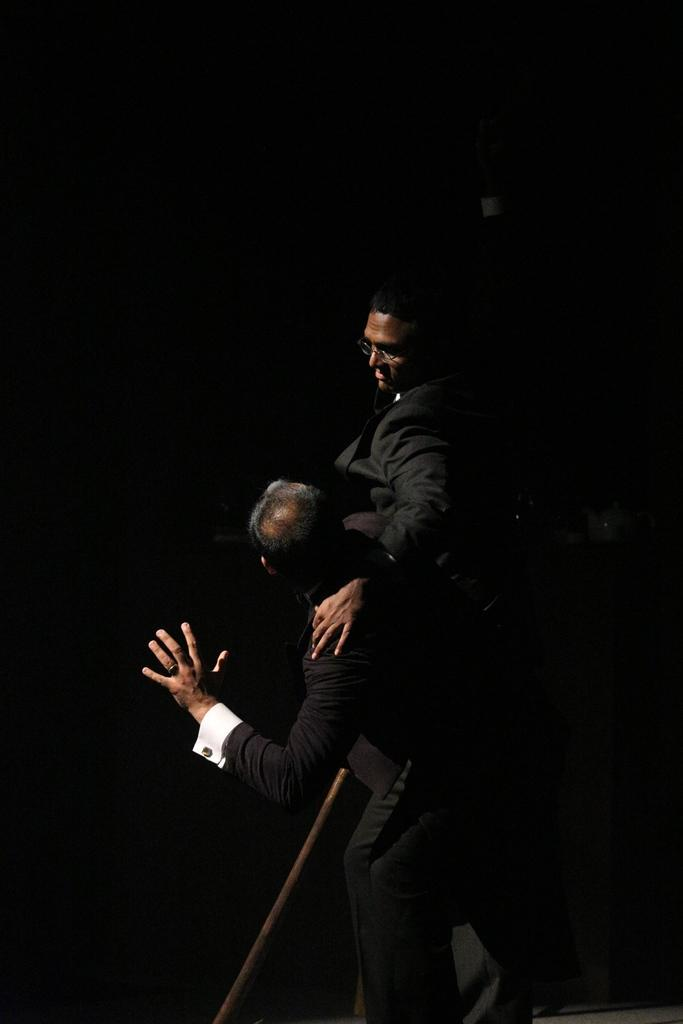How many people are present in the image? There are two people in the image. What object can be seen in the image besides the people? There is a rod in the image. What is the color of the background in the image? The background of the image is dark. How many beds can be seen in the image? There are no beds present in the image. What type of wound is visible on the people in the image? There is no wound visible on the people in the image. 